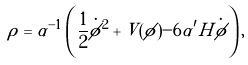Convert formula to latex. <formula><loc_0><loc_0><loc_500><loc_500>\rho = \alpha ^ { - 1 } \left ( \frac { 1 } { 2 } \dot { \phi } ^ { 2 } + V ( \phi ) - 6 \alpha ^ { \prime } H \dot { \phi } \right ) ,</formula> 